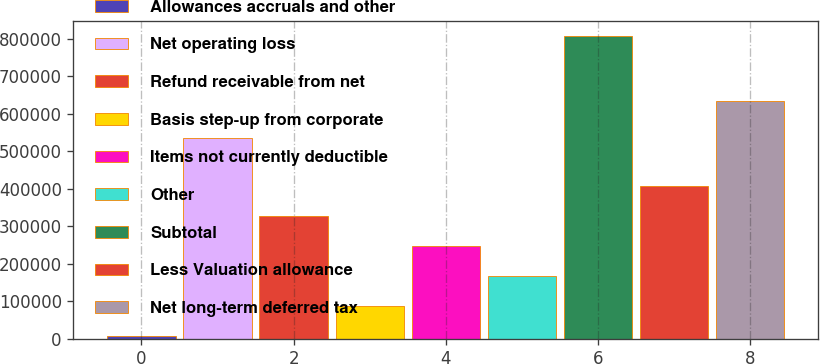<chart> <loc_0><loc_0><loc_500><loc_500><bar_chart><fcel>Allowances accruals and other<fcel>Net operating loss<fcel>Refund receivable from net<fcel>Basis step-up from corporate<fcel>Items not currently deductible<fcel>Other<fcel>Subtotal<fcel>Less Valuation allowance<fcel>Net long-term deferred tax<nl><fcel>6090<fcel>534529<fcel>326410<fcel>86170.1<fcel>246330<fcel>166250<fcel>806891<fcel>406490<fcel>633814<nl></chart> 